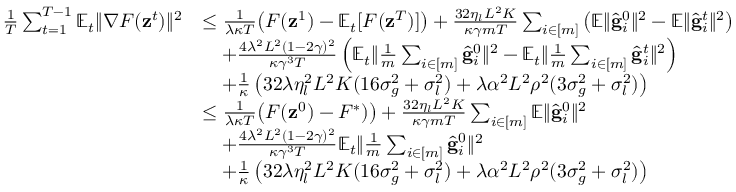Convert formula to latex. <formula><loc_0><loc_0><loc_500><loc_500>\begin{array} { r l } { \frac { 1 } { T } \sum _ { t = 1 } ^ { T - 1 } \mathbb { E } _ { t } \| \nabla F ( z ^ { t } ) \| ^ { 2 } } & { \leq \frac { 1 } { \lambda \kappa T } \left ( F ( z ^ { 1 } ) - \mathbb { E } _ { t } [ F ( z ^ { T } ) ] \right ) + \frac { 3 2 \eta _ { l } L ^ { 2 } K } { \kappa \gamma m T } \sum _ { i \in [ m ] } \left ( \mathbb { E } \| \hat { g } _ { i } ^ { 0 } \| ^ { 2 } - \mathbb { E } \| \hat { g } _ { i } ^ { t } \| ^ { 2 } \right ) } \\ & { \quad + \frac { 4 \lambda ^ { 2 } L ^ { 2 } ( 1 - 2 \gamma ) ^ { 2 } } { \kappa \gamma ^ { 3 } T } \left ( \mathbb { E } _ { t } \| \frac { 1 } { m } \sum _ { i \in [ m ] } \hat { g } _ { i } ^ { 0 } \| ^ { 2 } - \mathbb { E } _ { t } \| \frac { 1 } { m } \sum _ { i \in [ m ] } \hat { g } _ { i } ^ { t } \| ^ { 2 } \right ) } \\ & { \quad + \frac { 1 } { \kappa } \left ( 3 2 \lambda \eta _ { l } ^ { 2 } L ^ { 2 } K ( 1 6 \sigma _ { g } ^ { 2 } + \sigma _ { l } ^ { 2 } ) + \lambda \alpha ^ { 2 } L ^ { 2 } \rho ^ { 2 } ( 3 \sigma _ { g } ^ { 2 } + \sigma _ { l } ^ { 2 } ) \right ) } \\ & { \leq \frac { 1 } { \lambda \kappa T } \left ( F ( z ^ { 0 } ) - F ^ { * } ) \right ) + \frac { 3 2 \eta _ { l } L ^ { 2 } K } { \kappa \gamma m T } \sum _ { i \in [ m ] } \mathbb { E } \| \hat { g } _ { i } ^ { 0 } \| ^ { 2 } } \\ & { \quad + \frac { 4 \lambda ^ { 2 } L ^ { 2 } ( 1 - 2 \gamma ) ^ { 2 } } { \kappa \gamma ^ { 3 } T } \mathbb { E } _ { t } \| \frac { 1 } { m } \sum _ { i \in [ m ] } \hat { g } _ { i } ^ { 0 } \| ^ { 2 } } \\ & { \quad + \frac { 1 } { \kappa } \left ( 3 2 \lambda \eta _ { l } ^ { 2 } L ^ { 2 } K ( 1 6 \sigma _ { g } ^ { 2 } + \sigma _ { l } ^ { 2 } ) + \lambda \alpha ^ { 2 } L ^ { 2 } \rho ^ { 2 } ( 3 \sigma _ { g } ^ { 2 } + \sigma _ { l } ^ { 2 } ) \right ) } \end{array}</formula> 